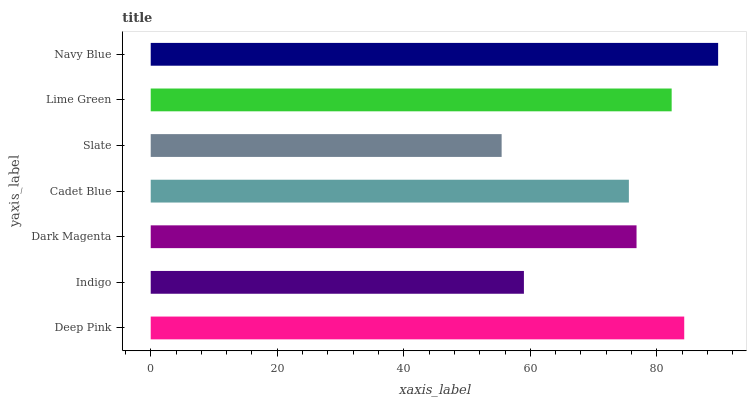Is Slate the minimum?
Answer yes or no. Yes. Is Navy Blue the maximum?
Answer yes or no. Yes. Is Indigo the minimum?
Answer yes or no. No. Is Indigo the maximum?
Answer yes or no. No. Is Deep Pink greater than Indigo?
Answer yes or no. Yes. Is Indigo less than Deep Pink?
Answer yes or no. Yes. Is Indigo greater than Deep Pink?
Answer yes or no. No. Is Deep Pink less than Indigo?
Answer yes or no. No. Is Dark Magenta the high median?
Answer yes or no. Yes. Is Dark Magenta the low median?
Answer yes or no. Yes. Is Cadet Blue the high median?
Answer yes or no. No. Is Slate the low median?
Answer yes or no. No. 